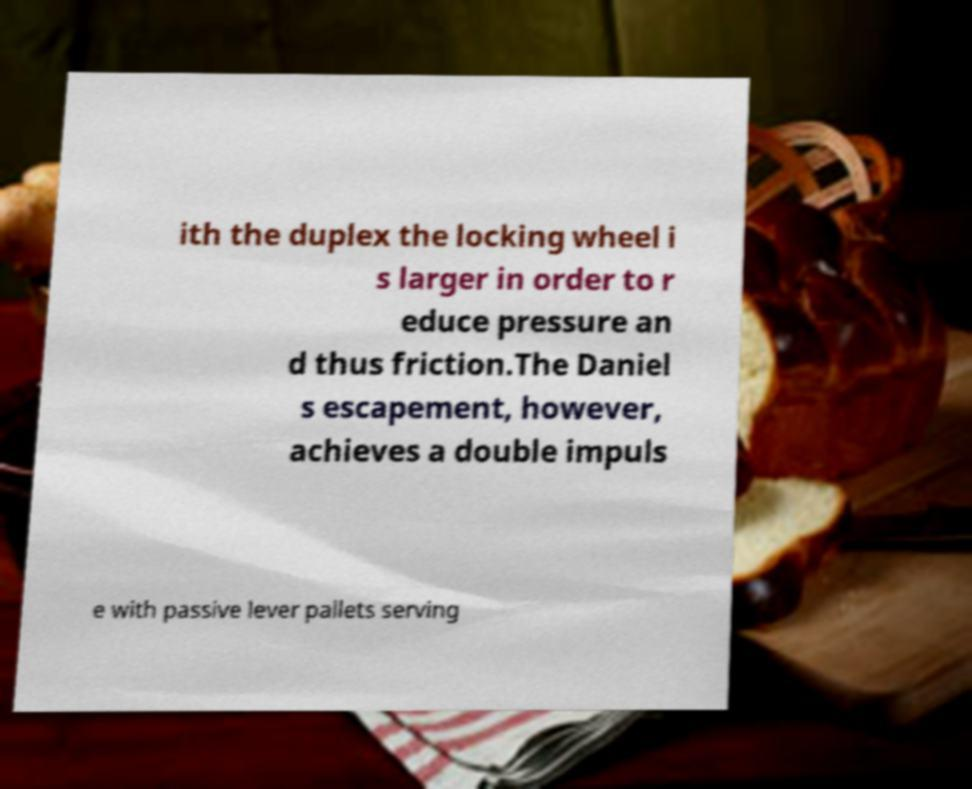Could you extract and type out the text from this image? ith the duplex the locking wheel i s larger in order to r educe pressure an d thus friction.The Daniel s escapement, however, achieves a double impuls e with passive lever pallets serving 